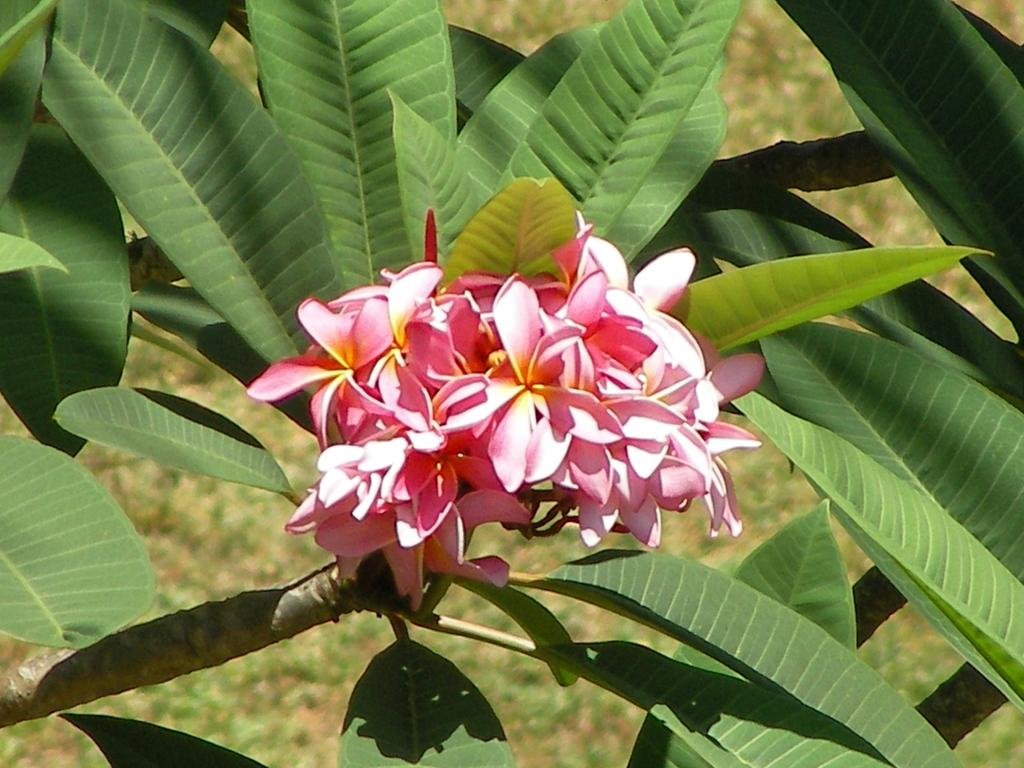What is located in the center of the image? There are flowers and leaves in the center of the image. Can you describe the flowers in the image? Unfortunately, the facts provided do not give any details about the flowers. What can be seen in the background of the image? There is grass visible in the background of the image. What type of animals can be seen at the zoo in the image? There is no zoo present in the image, so it is not possible to answer that question. 